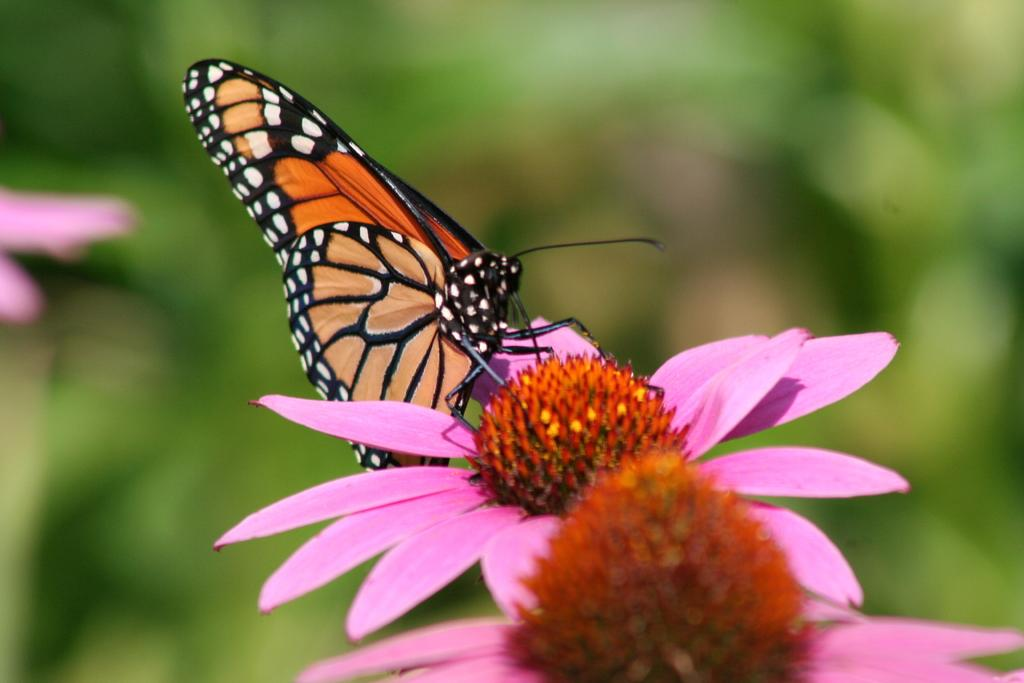What is the main subject of the image? The main subject of the image is a butterfly. Where is the butterfly located in the image? The butterfly is on a flower. What shape is the hole in the butterfly's wing in the image? There is no hole in the butterfly's wing in the image. 